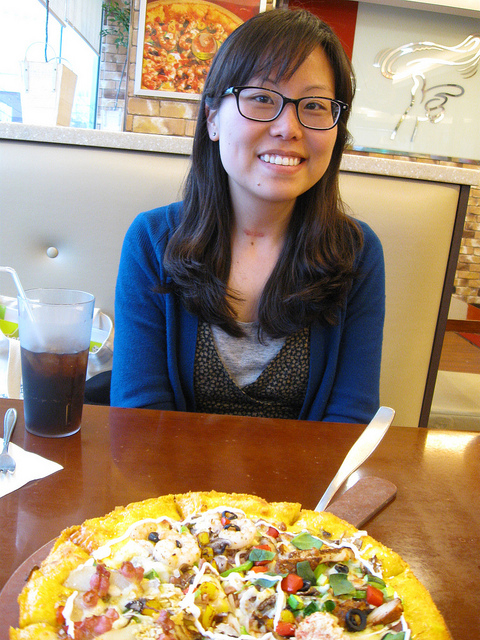How many blue airplanes are in the image? After carefully examining the image, I can confirm that there are no blue airplanes present. The image captures a person sitting at a table with a large, colorful pizza in front of them, which is likely the focus of the photograph. 